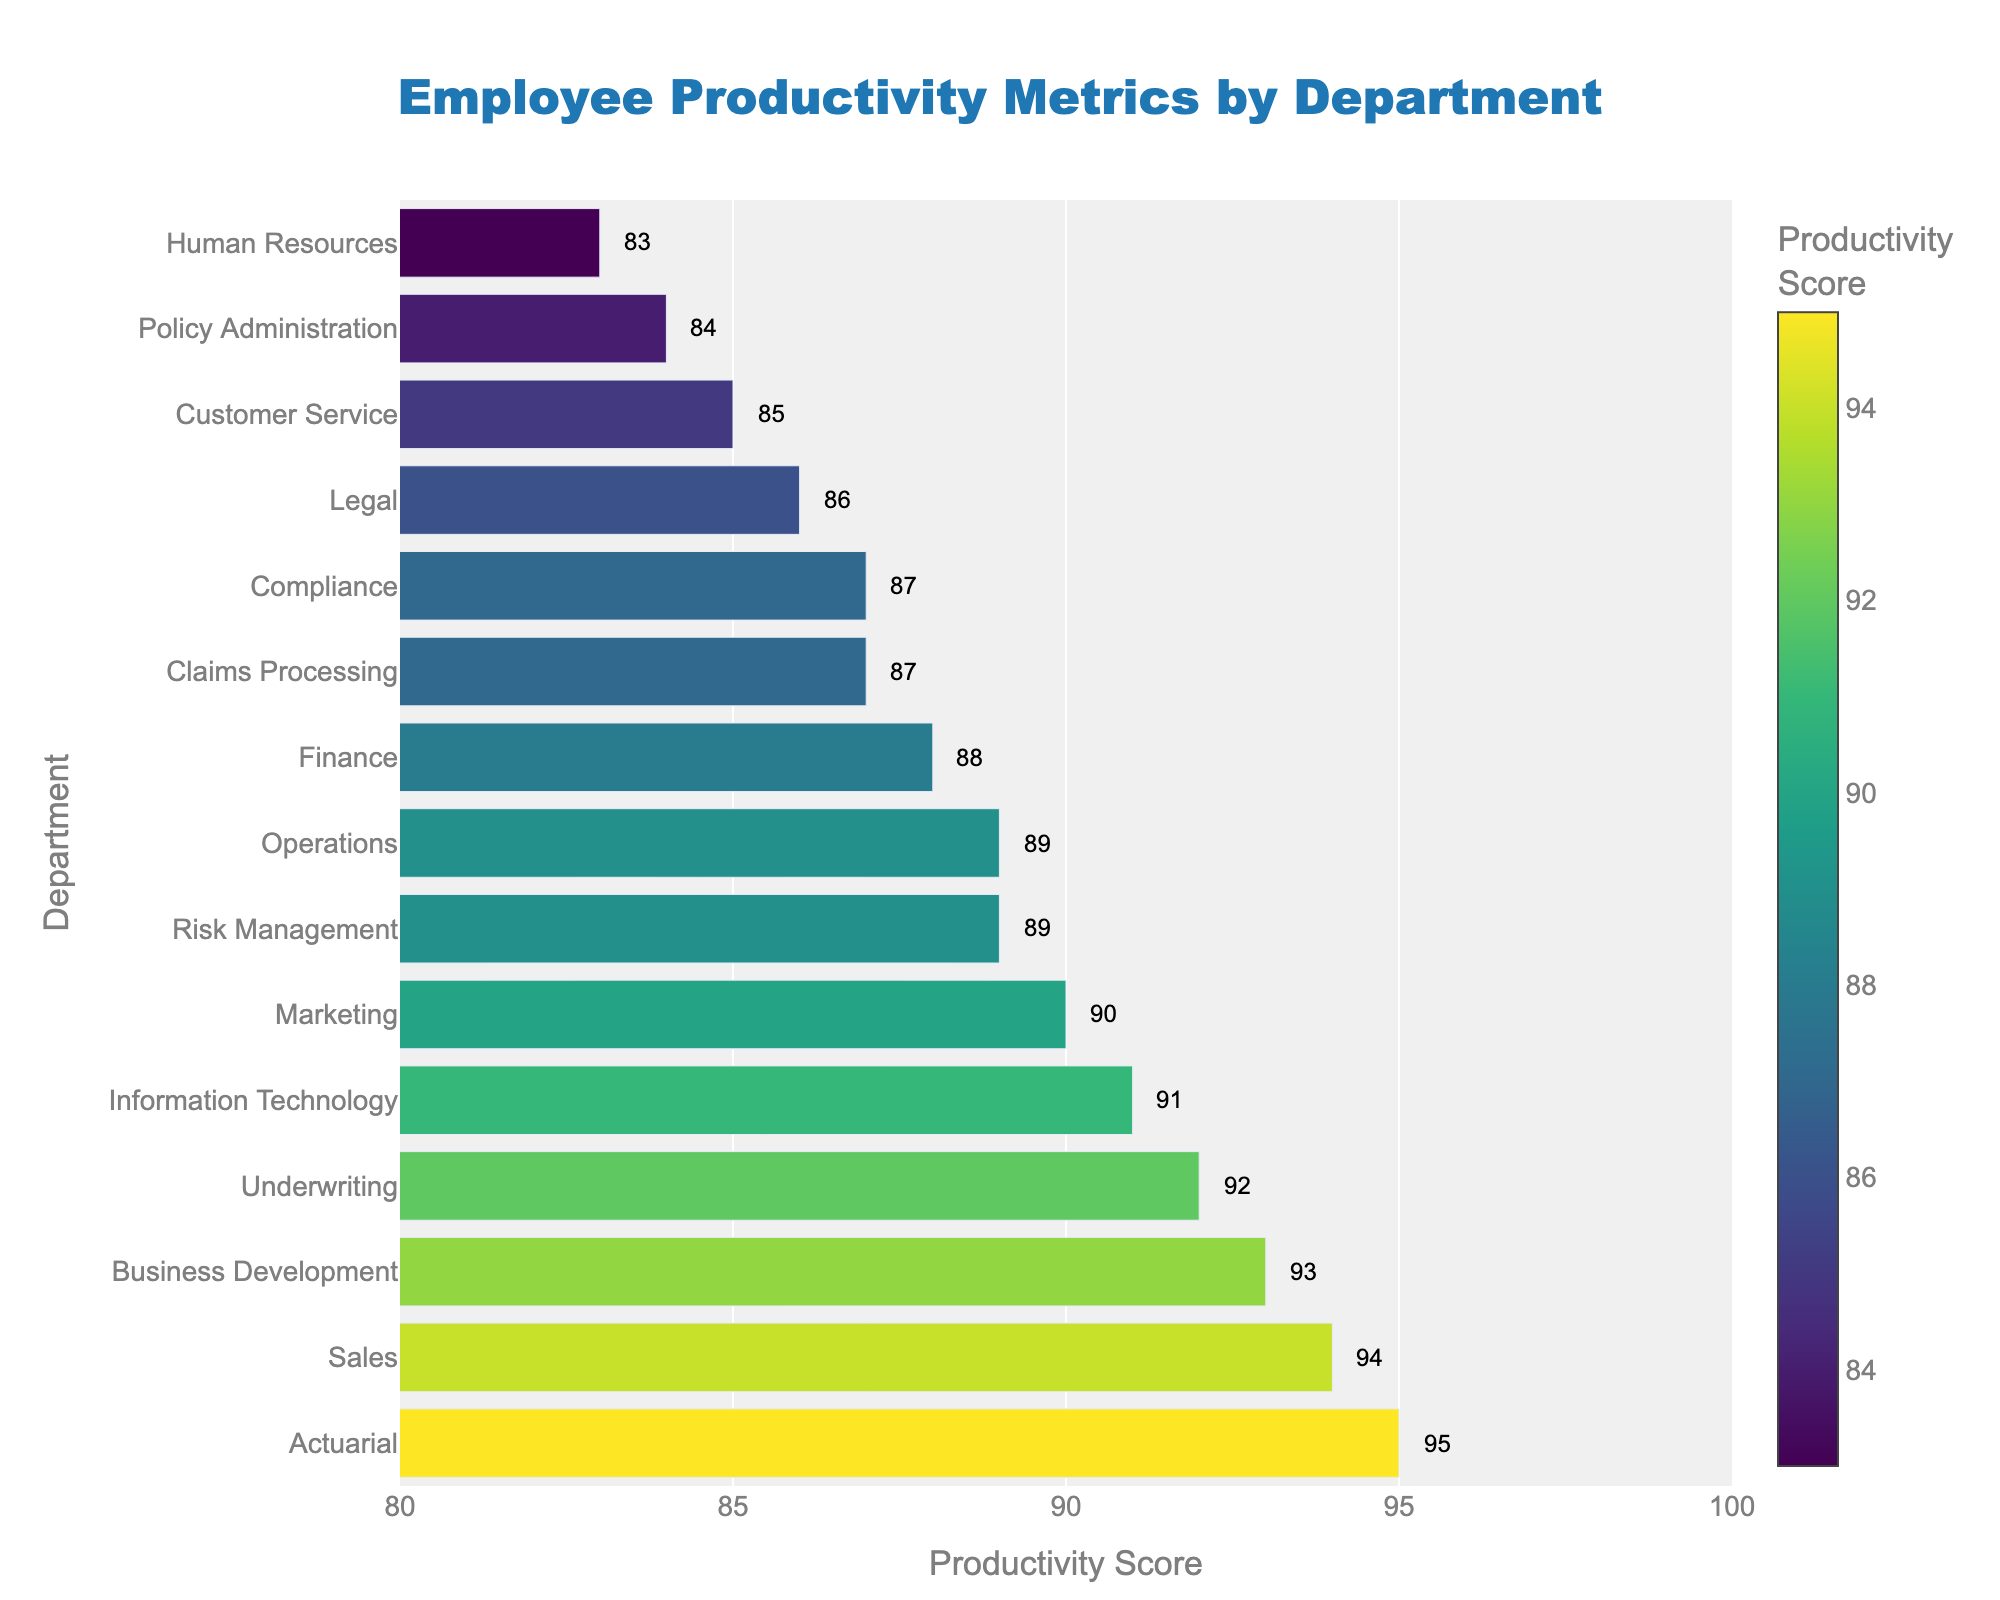What are the top three departments with the highest productivity scores? By examining the figure, the departments with the highest bars represent the highest productivity scores. Sorting through these, we find the top three are Actuarial (95), Sales (94), and Business Development (93).
Answer: Actuarial, Sales, Business Development How does the productivity score of Customer Service compare with Policy Administration? Locate the bars for Customer Service and Policy Administration and compare their lengths. The Productivity Score for Customer Service is 85 and for Policy Administration is 84, so Customer Service has a slightly higher score.
Answer: Customer Service is higher Which department has the lowest productivity score and what is it? Identify the shortest bar in the chart to find the least productive department. According to the chart, Human Resources has the lowest productivity score of 83.
Answer: Human Resources, 83 What is the total productivity score for the Claims Processing, Finance, and Legal departments combined? Locate the bars for Claims Processing (87), Finance (88), and Legal (86). Sum these values: 87 + 88 + 86 = 261.
Answer: 261 What is the average productivity score of all the departments shown in the figure? Sum all the productivity scores and divide by the total number of departments (15). Sum is 87+92+85+94+89+91+83+88+86+90+95+84+87+89+93 = 1,343. Average is 1,343/15 = 89.53.
Answer: 89.53 Which department has a productivity score closest to the overall average? The overall average calculated is 89.53. Compare each department's score to this average and see which is closest. Risk Management and Operations both have scores of 89, which is closest to 89.53.
Answer: Risk Management, Operations How many departments have productivity scores greater than 90? Count the number of bars that exceed the 90 value mark on the x-axis. These departments are Underwriting (92), Sales (94), Information Technology (91), Marketing (90), Actuarial (95), and Business Development (93). Thus, there are 6 departments.
Answer: 6 What is the difference in productivity scores between Underwriting and Information Technology? Find the bars corresponding to Underwriting (92) and Information Technology (91). The difference is 92 - 91 = 1.
Answer: 1 